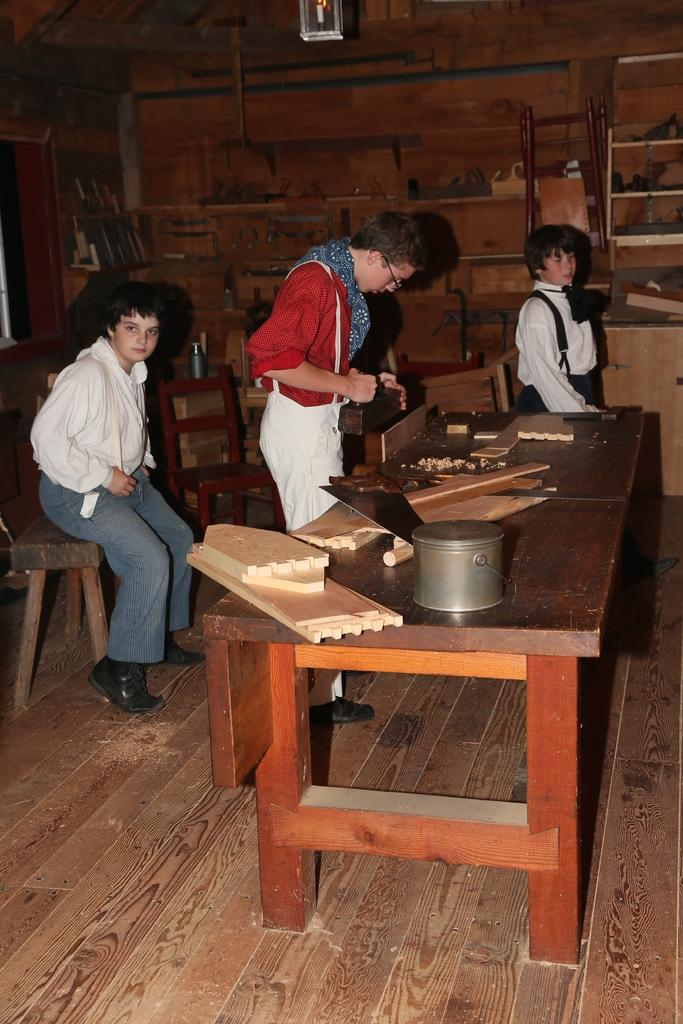How many people are in the image? There are three persons in the image. What are the persons doing in the image? The persons are standing around a table. What is on the table in the image? There are pieces of wood and a container on the table. What can be seen in the background of the image? There are objects visible in the background, including a wall and a lamp. What color are the eyes of the monkey in the image? There is no monkey present in the image, so there are no eyes to describe. 